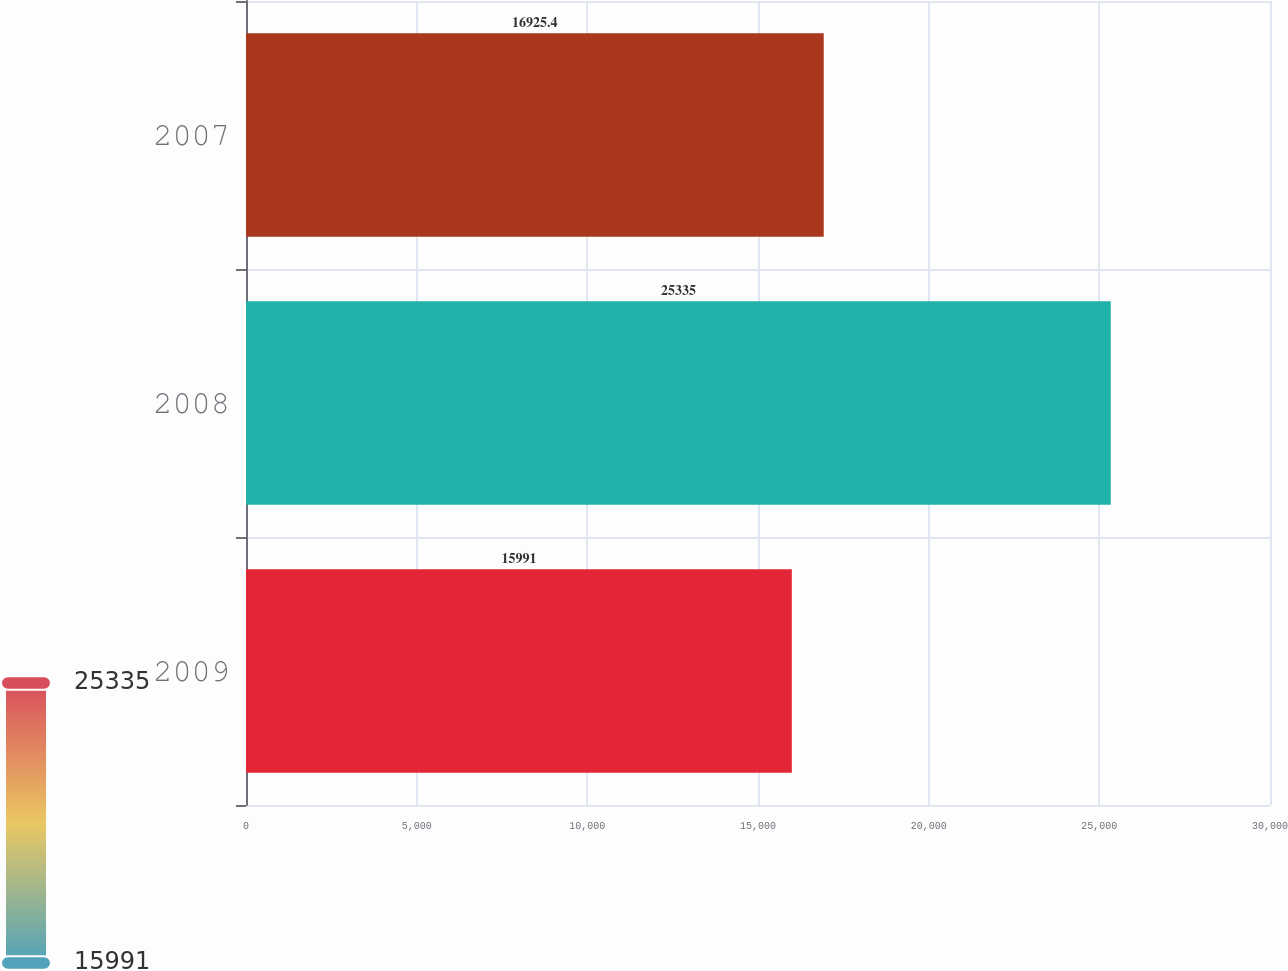Convert chart to OTSL. <chart><loc_0><loc_0><loc_500><loc_500><bar_chart><fcel>2009<fcel>2008<fcel>2007<nl><fcel>15991<fcel>25335<fcel>16925.4<nl></chart> 